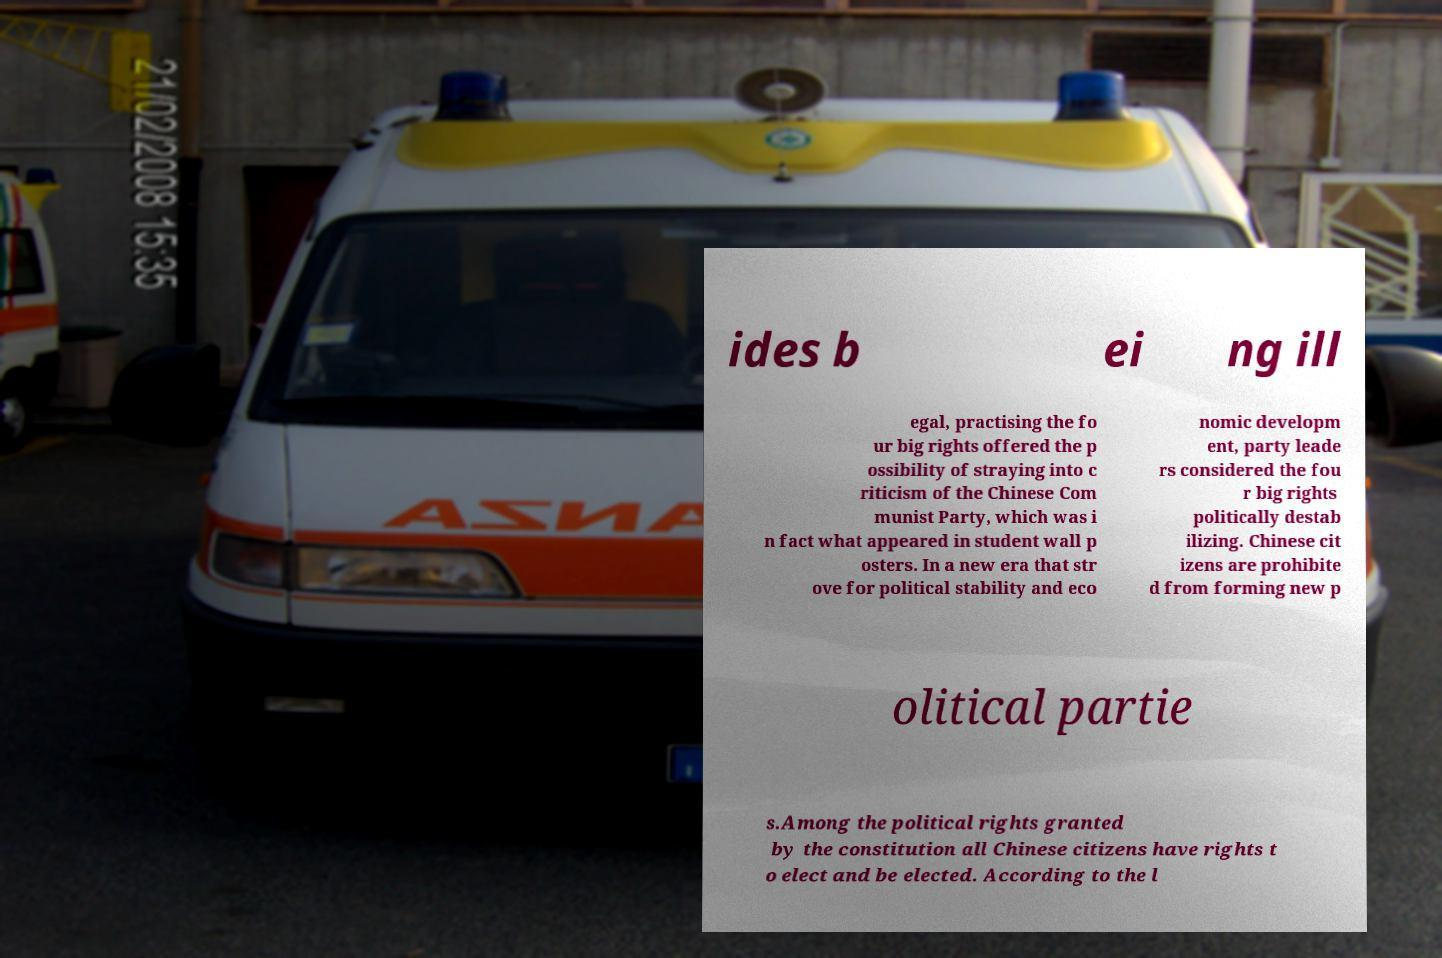There's text embedded in this image that I need extracted. Can you transcribe it verbatim? ides b ei ng ill egal, practising the fo ur big rights offered the p ossibility of straying into c riticism of the Chinese Com munist Party, which was i n fact what appeared in student wall p osters. In a new era that str ove for political stability and eco nomic developm ent, party leade rs considered the fou r big rights politically destab ilizing. Chinese cit izens are prohibite d from forming new p olitical partie s.Among the political rights granted by the constitution all Chinese citizens have rights t o elect and be elected. According to the l 